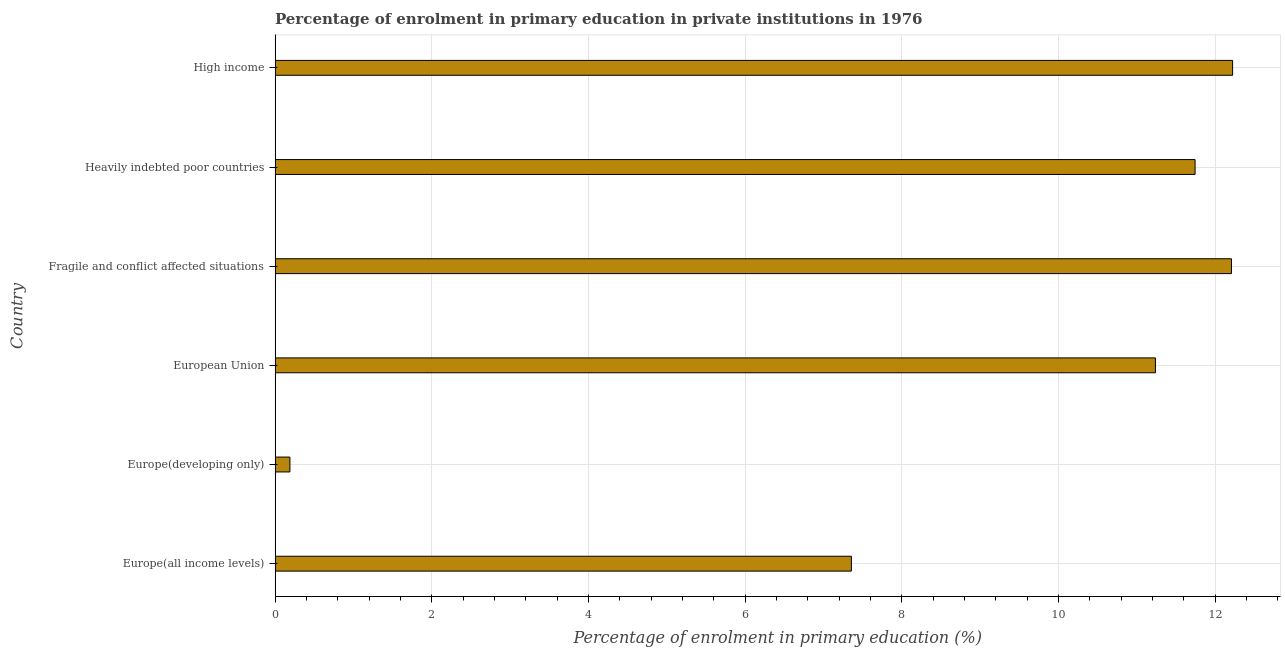Does the graph contain any zero values?
Your answer should be compact. No. Does the graph contain grids?
Keep it short and to the point. Yes. What is the title of the graph?
Make the answer very short. Percentage of enrolment in primary education in private institutions in 1976. What is the label or title of the X-axis?
Your answer should be very brief. Percentage of enrolment in primary education (%). What is the label or title of the Y-axis?
Offer a terse response. Country. What is the enrolment percentage in primary education in High income?
Your answer should be compact. 12.22. Across all countries, what is the maximum enrolment percentage in primary education?
Give a very brief answer. 12.22. Across all countries, what is the minimum enrolment percentage in primary education?
Offer a very short reply. 0.19. In which country was the enrolment percentage in primary education minimum?
Your response must be concise. Europe(developing only). What is the sum of the enrolment percentage in primary education?
Your answer should be compact. 54.96. What is the difference between the enrolment percentage in primary education in Fragile and conflict affected situations and Heavily indebted poor countries?
Your answer should be compact. 0.47. What is the average enrolment percentage in primary education per country?
Make the answer very short. 9.16. What is the median enrolment percentage in primary education?
Ensure brevity in your answer.  11.49. In how many countries, is the enrolment percentage in primary education greater than 9.6 %?
Make the answer very short. 4. What is the ratio of the enrolment percentage in primary education in European Union to that in High income?
Provide a succinct answer. 0.92. What is the difference between the highest and the second highest enrolment percentage in primary education?
Offer a terse response. 0.01. Is the sum of the enrolment percentage in primary education in Europe(all income levels) and European Union greater than the maximum enrolment percentage in primary education across all countries?
Offer a very short reply. Yes. What is the difference between the highest and the lowest enrolment percentage in primary education?
Keep it short and to the point. 12.03. Are the values on the major ticks of X-axis written in scientific E-notation?
Your answer should be compact. No. What is the Percentage of enrolment in primary education (%) in Europe(all income levels)?
Keep it short and to the point. 7.36. What is the Percentage of enrolment in primary education (%) of Europe(developing only)?
Ensure brevity in your answer.  0.19. What is the Percentage of enrolment in primary education (%) of European Union?
Offer a terse response. 11.24. What is the Percentage of enrolment in primary education (%) in Fragile and conflict affected situations?
Keep it short and to the point. 12.21. What is the Percentage of enrolment in primary education (%) of Heavily indebted poor countries?
Offer a terse response. 11.74. What is the Percentage of enrolment in primary education (%) of High income?
Ensure brevity in your answer.  12.22. What is the difference between the Percentage of enrolment in primary education (%) in Europe(all income levels) and Europe(developing only)?
Your answer should be very brief. 7.17. What is the difference between the Percentage of enrolment in primary education (%) in Europe(all income levels) and European Union?
Your answer should be compact. -3.88. What is the difference between the Percentage of enrolment in primary education (%) in Europe(all income levels) and Fragile and conflict affected situations?
Make the answer very short. -4.85. What is the difference between the Percentage of enrolment in primary education (%) in Europe(all income levels) and Heavily indebted poor countries?
Give a very brief answer. -4.39. What is the difference between the Percentage of enrolment in primary education (%) in Europe(all income levels) and High income?
Your answer should be compact. -4.87. What is the difference between the Percentage of enrolment in primary education (%) in Europe(developing only) and European Union?
Provide a short and direct response. -11.05. What is the difference between the Percentage of enrolment in primary education (%) in Europe(developing only) and Fragile and conflict affected situations?
Offer a terse response. -12.02. What is the difference between the Percentage of enrolment in primary education (%) in Europe(developing only) and Heavily indebted poor countries?
Offer a very short reply. -11.55. What is the difference between the Percentage of enrolment in primary education (%) in Europe(developing only) and High income?
Your response must be concise. -12.03. What is the difference between the Percentage of enrolment in primary education (%) in European Union and Fragile and conflict affected situations?
Give a very brief answer. -0.97. What is the difference between the Percentage of enrolment in primary education (%) in European Union and Heavily indebted poor countries?
Your answer should be very brief. -0.51. What is the difference between the Percentage of enrolment in primary education (%) in European Union and High income?
Provide a succinct answer. -0.99. What is the difference between the Percentage of enrolment in primary education (%) in Fragile and conflict affected situations and Heavily indebted poor countries?
Ensure brevity in your answer.  0.46. What is the difference between the Percentage of enrolment in primary education (%) in Fragile and conflict affected situations and High income?
Offer a very short reply. -0.01. What is the difference between the Percentage of enrolment in primary education (%) in Heavily indebted poor countries and High income?
Your answer should be compact. -0.48. What is the ratio of the Percentage of enrolment in primary education (%) in Europe(all income levels) to that in Europe(developing only)?
Offer a terse response. 38.85. What is the ratio of the Percentage of enrolment in primary education (%) in Europe(all income levels) to that in European Union?
Your response must be concise. 0.66. What is the ratio of the Percentage of enrolment in primary education (%) in Europe(all income levels) to that in Fragile and conflict affected situations?
Provide a short and direct response. 0.6. What is the ratio of the Percentage of enrolment in primary education (%) in Europe(all income levels) to that in Heavily indebted poor countries?
Offer a very short reply. 0.63. What is the ratio of the Percentage of enrolment in primary education (%) in Europe(all income levels) to that in High income?
Your response must be concise. 0.6. What is the ratio of the Percentage of enrolment in primary education (%) in Europe(developing only) to that in European Union?
Offer a very short reply. 0.02. What is the ratio of the Percentage of enrolment in primary education (%) in Europe(developing only) to that in Fragile and conflict affected situations?
Keep it short and to the point. 0.02. What is the ratio of the Percentage of enrolment in primary education (%) in Europe(developing only) to that in Heavily indebted poor countries?
Make the answer very short. 0.02. What is the ratio of the Percentage of enrolment in primary education (%) in Europe(developing only) to that in High income?
Your answer should be compact. 0.01. What is the ratio of the Percentage of enrolment in primary education (%) in European Union to that in Fragile and conflict affected situations?
Offer a very short reply. 0.92. What is the ratio of the Percentage of enrolment in primary education (%) in European Union to that in High income?
Give a very brief answer. 0.92. What is the ratio of the Percentage of enrolment in primary education (%) in Fragile and conflict affected situations to that in Heavily indebted poor countries?
Your answer should be compact. 1.04. What is the ratio of the Percentage of enrolment in primary education (%) in Fragile and conflict affected situations to that in High income?
Your answer should be very brief. 1. What is the ratio of the Percentage of enrolment in primary education (%) in Heavily indebted poor countries to that in High income?
Offer a terse response. 0.96. 